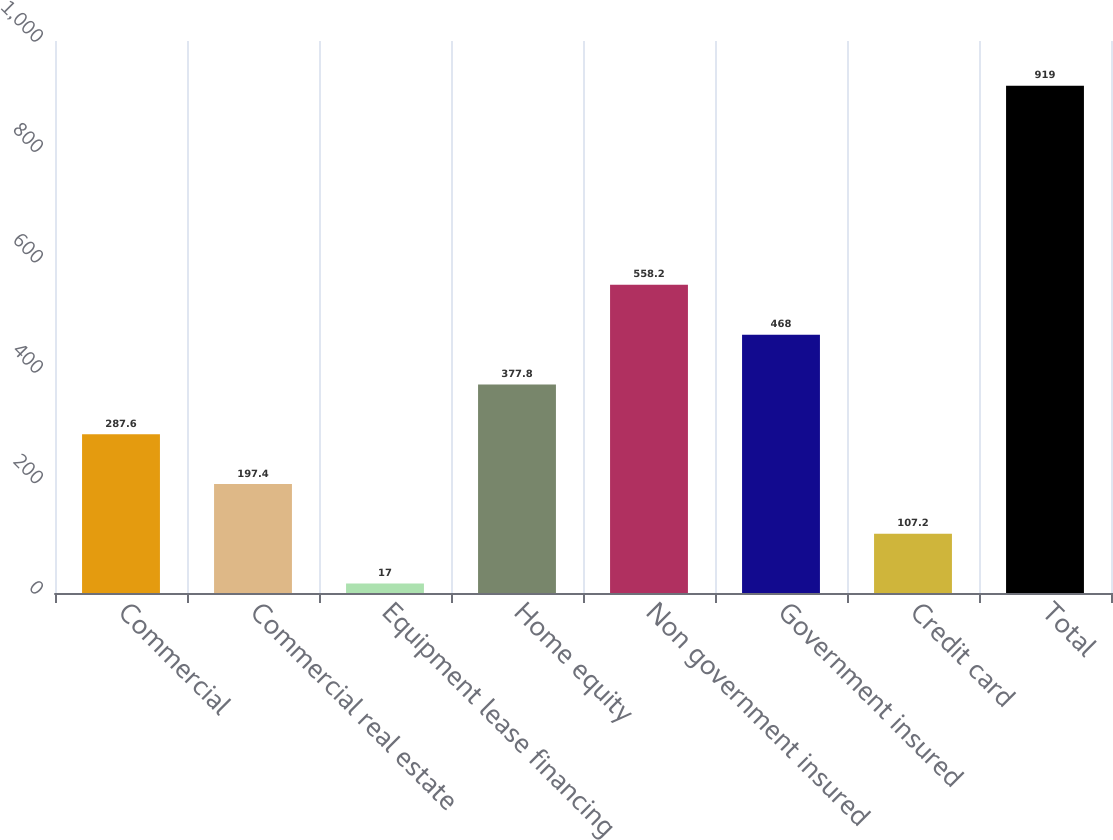Convert chart. <chart><loc_0><loc_0><loc_500><loc_500><bar_chart><fcel>Commercial<fcel>Commercial real estate<fcel>Equipment lease financing<fcel>Home equity<fcel>Non government insured<fcel>Government insured<fcel>Credit card<fcel>Total<nl><fcel>287.6<fcel>197.4<fcel>17<fcel>377.8<fcel>558.2<fcel>468<fcel>107.2<fcel>919<nl></chart> 